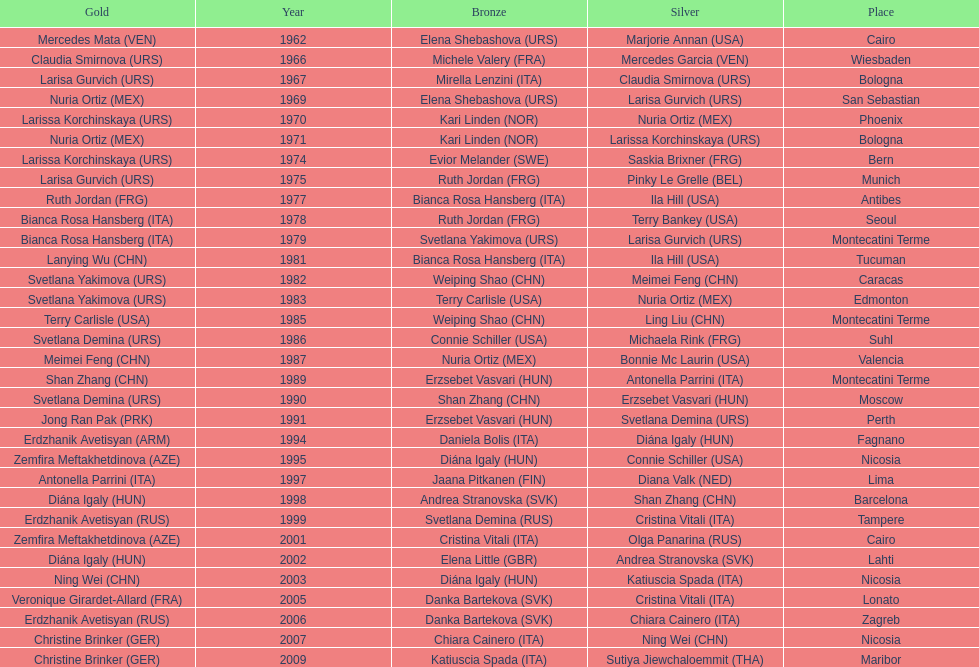Who won the only gold medal in 1962? Mercedes Mata. 